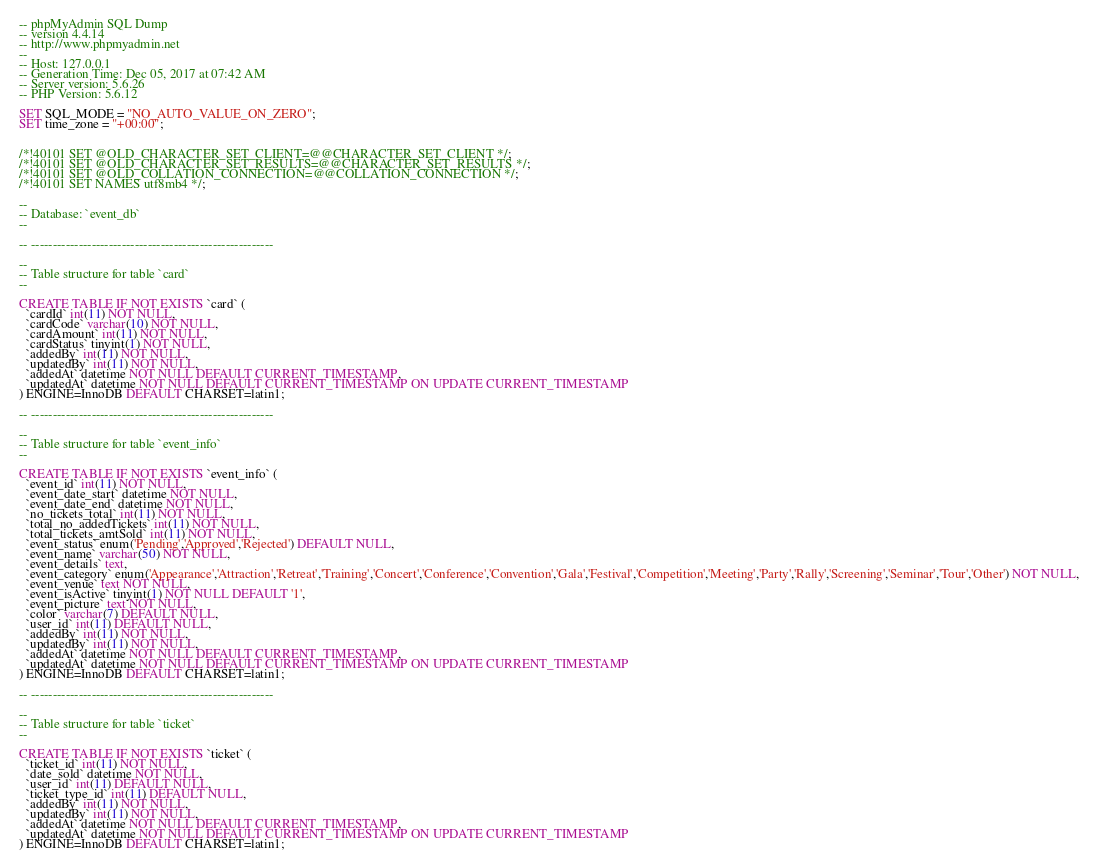<code> <loc_0><loc_0><loc_500><loc_500><_SQL_>-- phpMyAdmin SQL Dump
-- version 4.4.14
-- http://www.phpmyadmin.net
--
-- Host: 127.0.0.1
-- Generation Time: Dec 05, 2017 at 07:42 AM
-- Server version: 5.6.26
-- PHP Version: 5.6.12

SET SQL_MODE = "NO_AUTO_VALUE_ON_ZERO";
SET time_zone = "+00:00";


/*!40101 SET @OLD_CHARACTER_SET_CLIENT=@@CHARACTER_SET_CLIENT */;
/*!40101 SET @OLD_CHARACTER_SET_RESULTS=@@CHARACTER_SET_RESULTS */;
/*!40101 SET @OLD_COLLATION_CONNECTION=@@COLLATION_CONNECTION */;
/*!40101 SET NAMES utf8mb4 */;

--
-- Database: `event_db`
--

-- --------------------------------------------------------

--
-- Table structure for table `card`
--

CREATE TABLE IF NOT EXISTS `card` (
  `cardId` int(11) NOT NULL,
  `cardCode` varchar(10) NOT NULL,
  `cardAmount` int(11) NOT NULL,
  `cardStatus` tinyint(1) NOT NULL,
  `addedBy` int(11) NOT NULL,
  `updatedBy` int(11) NOT NULL,
  `addedAt` datetime NOT NULL DEFAULT CURRENT_TIMESTAMP,
  `updatedAt` datetime NOT NULL DEFAULT CURRENT_TIMESTAMP ON UPDATE CURRENT_TIMESTAMP
) ENGINE=InnoDB DEFAULT CHARSET=latin1;

-- --------------------------------------------------------

--
-- Table structure for table `event_info`
--

CREATE TABLE IF NOT EXISTS `event_info` (
  `event_id` int(11) NOT NULL,
  `event_date_start` datetime NOT NULL,
  `event_date_end` datetime NOT NULL,
  `no_tickets_total` int(11) NOT NULL,
  `total_no_addedTickets` int(11) NOT NULL,
  `total_tickets_amtSold` int(11) NOT NULL,
  `event_status` enum('Pending','Approved','Rejected') DEFAULT NULL,
  `event_name` varchar(50) NOT NULL,
  `event_details` text,
  `event_category` enum('Appearance','Attraction','Retreat','Training','Concert','Conference','Convention','Gala','Festival','Competition','Meeting','Party','Rally','Screening','Seminar','Tour','Other') NOT NULL,
  `event_venue` text NOT NULL,
  `event_isActive` tinyint(1) NOT NULL DEFAULT '1',
  `event_picture` text NOT NULL,
  `color` varchar(7) DEFAULT NULL,
  `user_id` int(11) DEFAULT NULL,
  `addedBy` int(11) NOT NULL,
  `updatedBy` int(11) NOT NULL,
  `addedAt` datetime NOT NULL DEFAULT CURRENT_TIMESTAMP,
  `updatedAt` datetime NOT NULL DEFAULT CURRENT_TIMESTAMP ON UPDATE CURRENT_TIMESTAMP
) ENGINE=InnoDB DEFAULT CHARSET=latin1;

-- --------------------------------------------------------

--
-- Table structure for table `ticket`
--

CREATE TABLE IF NOT EXISTS `ticket` (
  `ticket_id` int(11) NOT NULL,
  `date_sold` datetime NOT NULL,
  `user_id` int(11) DEFAULT NULL,
  `ticket_type_id` int(11) DEFAULT NULL,
  `addedBy` int(11) NOT NULL,
  `updatedBy` int(11) NOT NULL,
  `addedAt` datetime NOT NULL DEFAULT CURRENT_TIMESTAMP,
  `updatedAt` datetime NOT NULL DEFAULT CURRENT_TIMESTAMP ON UPDATE CURRENT_TIMESTAMP
) ENGINE=InnoDB DEFAULT CHARSET=latin1;
</code> 